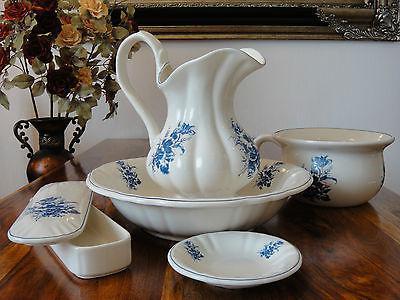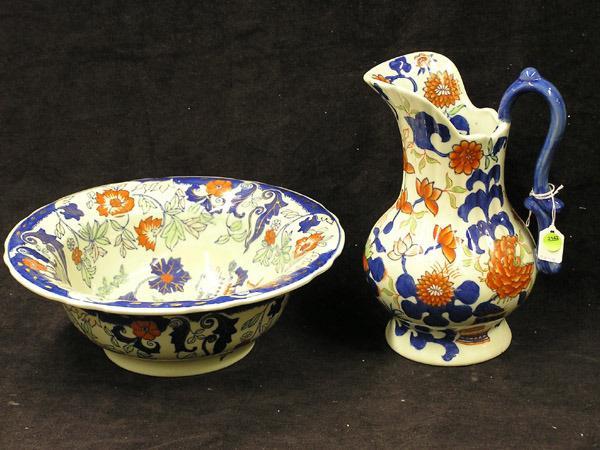The first image is the image on the left, the second image is the image on the right. Assess this claim about the two images: "At least one image includes a pitcher with a graceful curving handle instead of a squared one.". Correct or not? Answer yes or no. Yes. The first image is the image on the left, the second image is the image on the right. Evaluate the accuracy of this statement regarding the images: "One of two bowl and pitcher sets is predominantly white with only a pattern on the upper edge of the pitcher and the bowl.". Is it true? Answer yes or no. No. 